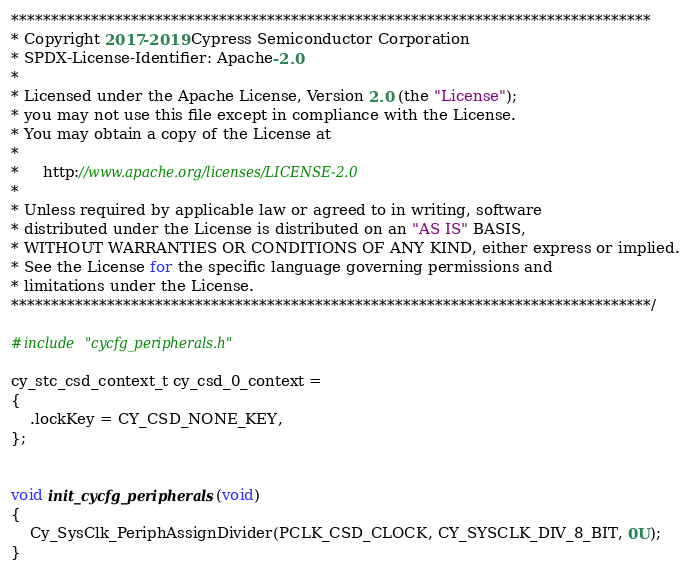Convert code to text. <code><loc_0><loc_0><loc_500><loc_500><_C_>********************************************************************************
* Copyright 2017-2019 Cypress Semiconductor Corporation
* SPDX-License-Identifier: Apache-2.0
*
* Licensed under the Apache License, Version 2.0 (the "License");
* you may not use this file except in compliance with the License.
* You may obtain a copy of the License at
*
*     http://www.apache.org/licenses/LICENSE-2.0
*
* Unless required by applicable law or agreed to in writing, software
* distributed under the License is distributed on an "AS IS" BASIS,
* WITHOUT WARRANTIES OR CONDITIONS OF ANY KIND, either express or implied.
* See the License for the specific language governing permissions and
* limitations under the License.
********************************************************************************/

#include "cycfg_peripherals.h"

cy_stc_csd_context_t cy_csd_0_context = 
{
	.lockKey = CY_CSD_NONE_KEY,
};


void init_cycfg_peripherals(void)
{
	Cy_SysClk_PeriphAssignDivider(PCLK_CSD_CLOCK, CY_SYSCLK_DIV_8_BIT, 0U);
}
</code> 